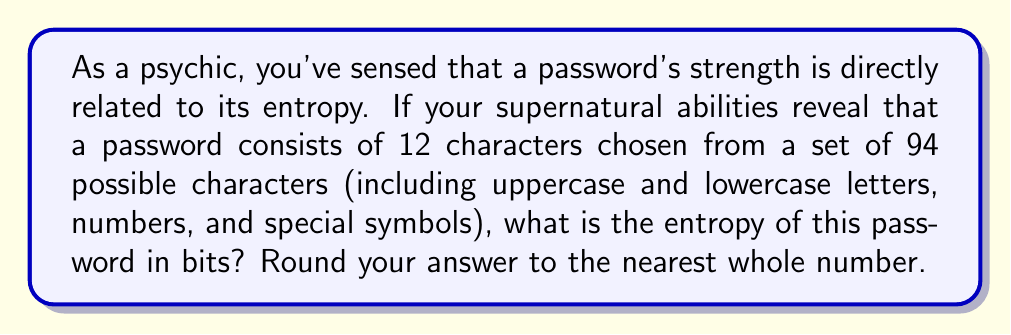Could you help me with this problem? To calculate the entropy of a password, we use the formula:

$$E = L \log_2(R)$$

Where:
$E$ = Entropy in bits
$L$ = Length of the password
$R$ = Range of possible characters

Step 1: Identify the values
$L = 12$ (characters in the password)
$R = 94$ (possible characters to choose from)

Step 2: Apply the formula
$$E = 12 \log_2(94)$$

Step 3: Calculate $\log_2(94)$
$\log_2(94) \approx 6.5545$

Step 4: Multiply by the length
$$E = 12 \times 6.5545 \approx 78.6540$$

Step 5: Round to the nearest whole number
$78.6540$ rounds to $79$

Therefore, the entropy of the password is approximately 79 bits.
Answer: 79 bits 